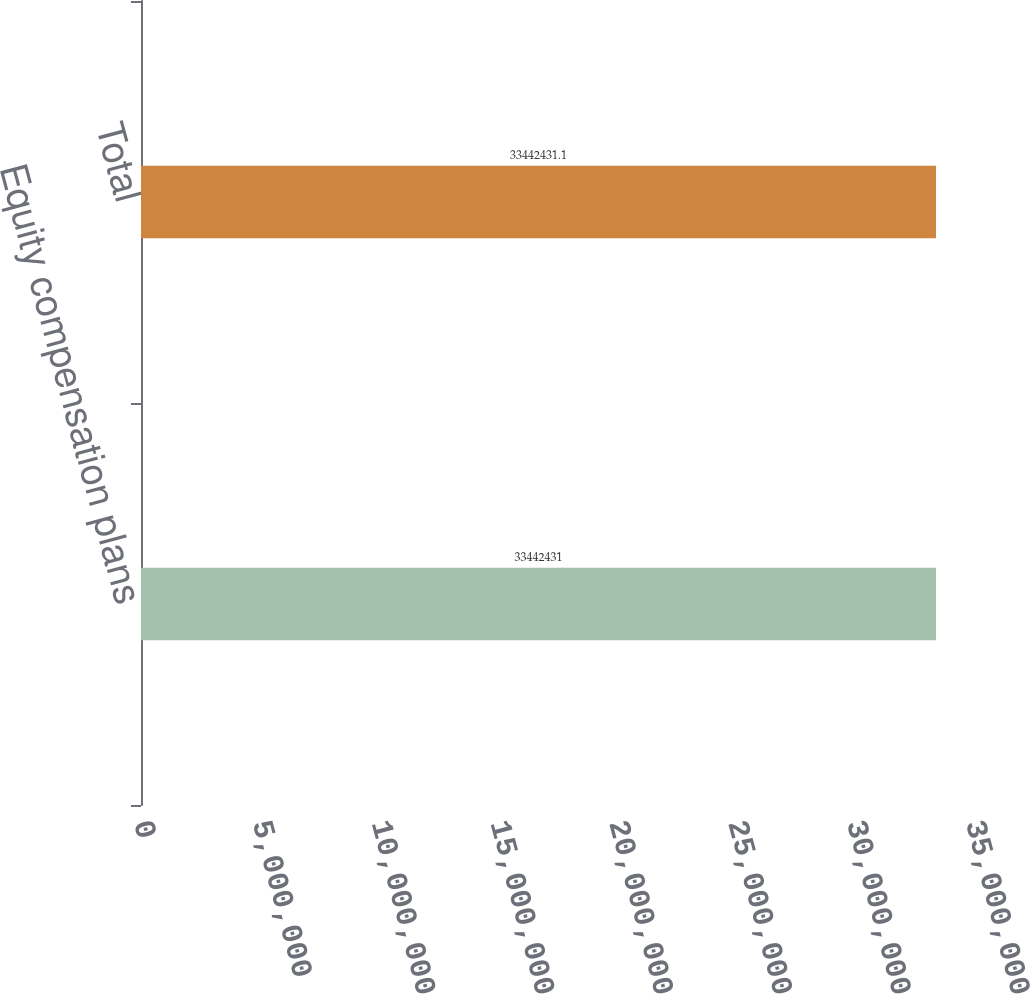Convert chart to OTSL. <chart><loc_0><loc_0><loc_500><loc_500><bar_chart><fcel>Equity compensation plans<fcel>Total<nl><fcel>3.34424e+07<fcel>3.34424e+07<nl></chart> 